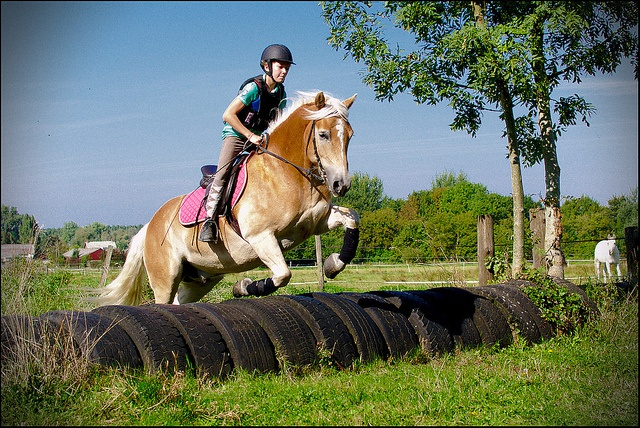Describe the objects in this image and their specific colors. I can see horse in black, ivory, and tan tones, people in black, lightgray, lightpink, and gray tones, and horse in black, lightgray, gray, darkgray, and darkgreen tones in this image. 